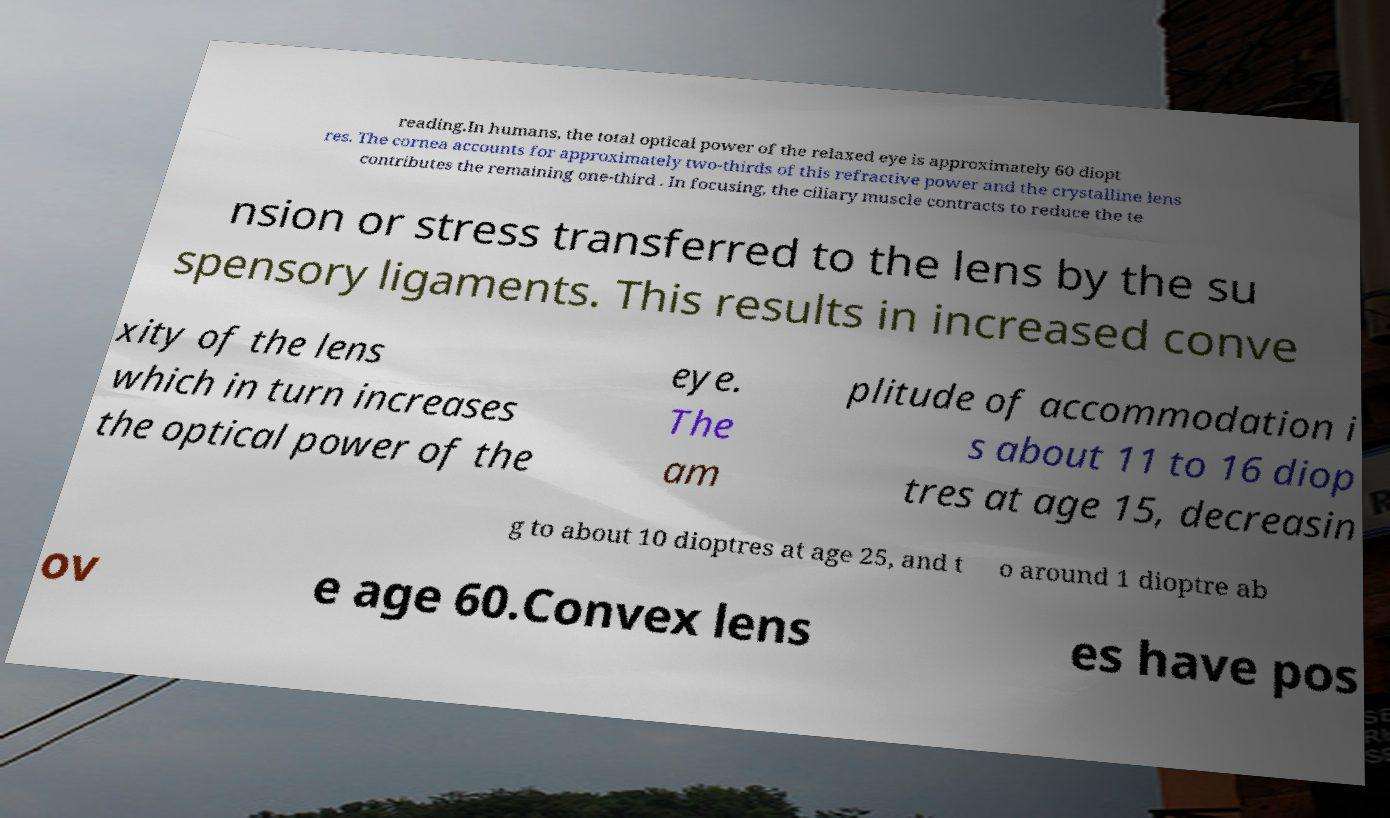What messages or text are displayed in this image? I need them in a readable, typed format. reading.In humans, the total optical power of the relaxed eye is approximately 60 diopt res. The cornea accounts for approximately two-thirds of this refractive power and the crystalline lens contributes the remaining one-third . In focusing, the ciliary muscle contracts to reduce the te nsion or stress transferred to the lens by the su spensory ligaments. This results in increased conve xity of the lens which in turn increases the optical power of the eye. The am plitude of accommodation i s about 11 to 16 diop tres at age 15, decreasin g to about 10 dioptres at age 25, and t o around 1 dioptre ab ov e age 60.Convex lens es have pos 